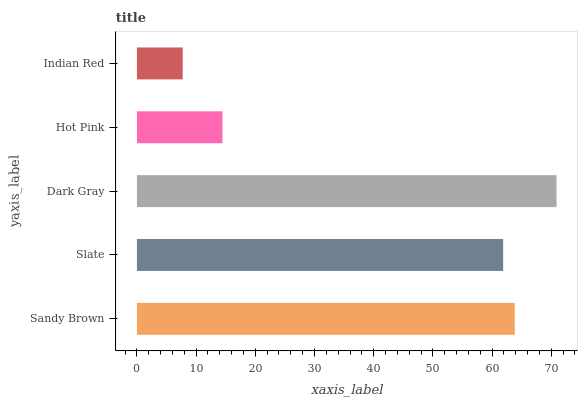Is Indian Red the minimum?
Answer yes or no. Yes. Is Dark Gray the maximum?
Answer yes or no. Yes. Is Slate the minimum?
Answer yes or no. No. Is Slate the maximum?
Answer yes or no. No. Is Sandy Brown greater than Slate?
Answer yes or no. Yes. Is Slate less than Sandy Brown?
Answer yes or no. Yes. Is Slate greater than Sandy Brown?
Answer yes or no. No. Is Sandy Brown less than Slate?
Answer yes or no. No. Is Slate the high median?
Answer yes or no. Yes. Is Slate the low median?
Answer yes or no. Yes. Is Sandy Brown the high median?
Answer yes or no. No. Is Dark Gray the low median?
Answer yes or no. No. 